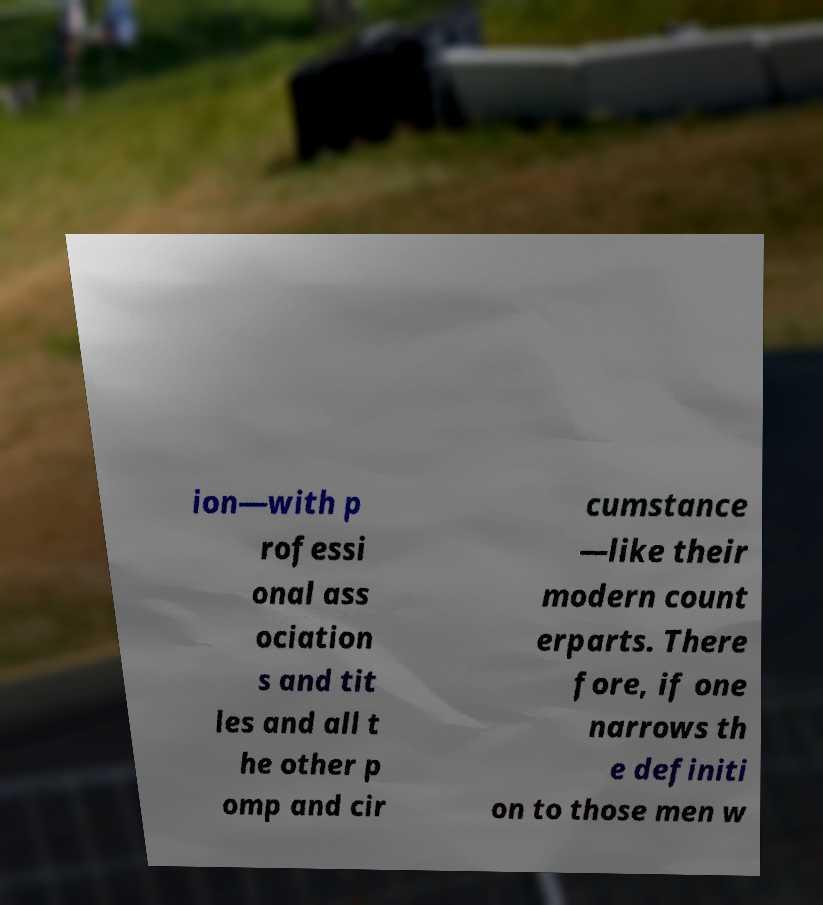Can you accurately transcribe the text from the provided image for me? ion—with p rofessi onal ass ociation s and tit les and all t he other p omp and cir cumstance —like their modern count erparts. There fore, if one narrows th e definiti on to those men w 